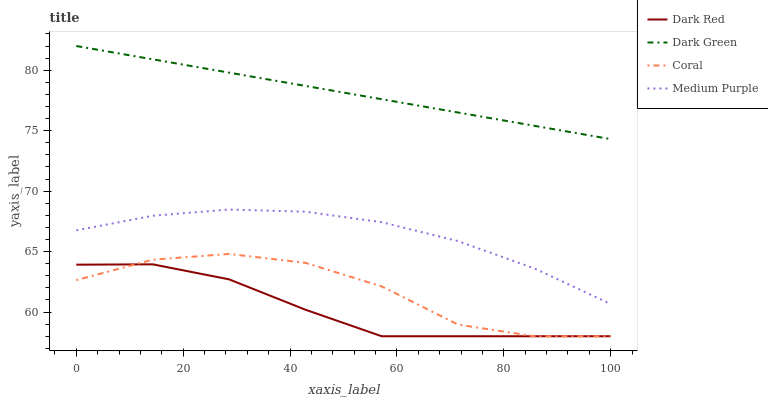Does Dark Red have the minimum area under the curve?
Answer yes or no. Yes. Does Dark Green have the maximum area under the curve?
Answer yes or no. Yes. Does Coral have the minimum area under the curve?
Answer yes or no. No. Does Coral have the maximum area under the curve?
Answer yes or no. No. Is Dark Green the smoothest?
Answer yes or no. Yes. Is Coral the roughest?
Answer yes or no. Yes. Is Dark Red the smoothest?
Answer yes or no. No. Is Dark Red the roughest?
Answer yes or no. No. Does Dark Red have the lowest value?
Answer yes or no. Yes. Does Dark Green have the lowest value?
Answer yes or no. No. Does Dark Green have the highest value?
Answer yes or no. Yes. Does Coral have the highest value?
Answer yes or no. No. Is Coral less than Medium Purple?
Answer yes or no. Yes. Is Medium Purple greater than Dark Red?
Answer yes or no. Yes. Does Dark Red intersect Coral?
Answer yes or no. Yes. Is Dark Red less than Coral?
Answer yes or no. No. Is Dark Red greater than Coral?
Answer yes or no. No. Does Coral intersect Medium Purple?
Answer yes or no. No. 